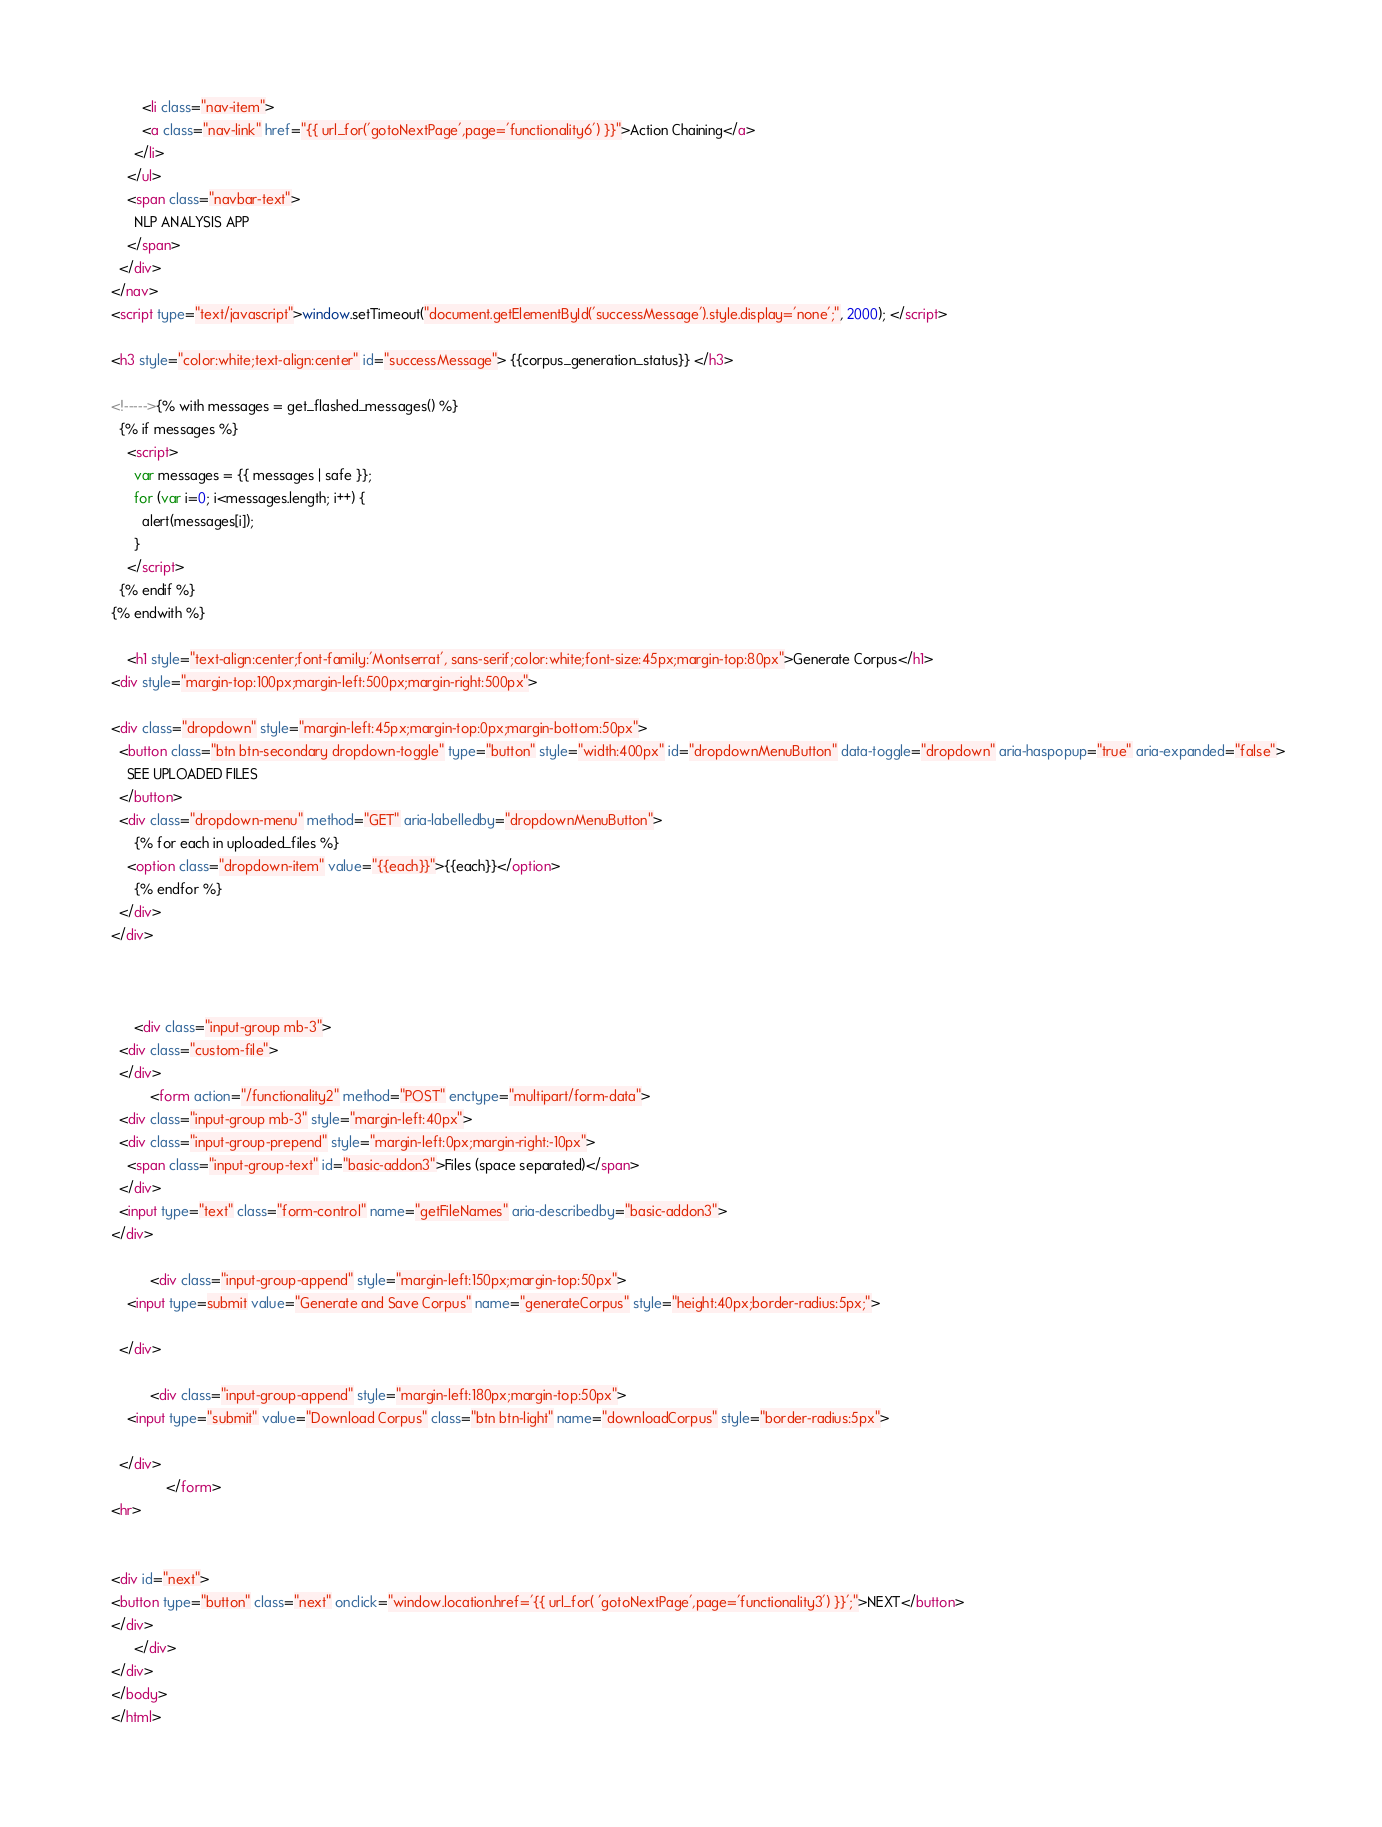Convert code to text. <code><loc_0><loc_0><loc_500><loc_500><_HTML_>        <li class="nav-item">
        <a class="nav-link" href="{{ url_for('gotoNextPage',page='functionality6') }}">Action Chaining</a>
      </li>
    </ul>
    <span class="navbar-text">
      NLP ANALYSIS APP
    </span>
  </div>
</nav>
<script type="text/javascript">window.setTimeout("document.getElementById('successMessage').style.display='none';", 2000); </script>

<h3 style="color:white;text-align:center" id="successMessage"> {{corpus_generation_status}} </h3>

<!----->{% with messages = get_flashed_messages() %}
  {% if messages %}
    <script>
      var messages = {{ messages | safe }};
      for (var i=0; i<messages.length; i++) {
        alert(messages[i]);
      }
    </script>
  {% endif %}
{% endwith %}

    <h1 style="text-align:center;font-family:'Montserrat', sans-serif;color:white;font-size:45px;margin-top:80px">Generate Corpus</h1>
<div style="margin-top:100px;margin-left:500px;margin-right:500px">

<div class="dropdown" style="margin-left:45px;margin-top:0px;margin-bottom:50px">
  <button class="btn btn-secondary dropdown-toggle" type="button" style="width:400px" id="dropdownMenuButton" data-toggle="dropdown" aria-haspopup="true" aria-expanded="false">
    SEE UPLOADED FILES
  </button>
  <div class="dropdown-menu" method="GET" aria-labelledby="dropdownMenuButton">
      {% for each in uploaded_files %}
    <option class="dropdown-item" value="{{each}}">{{each}}</option>
      {% endfor %}
  </div>
</div>



      <div class="input-group mb-3">
  <div class="custom-file">
  </div>
          <form action="/functionality2" method="POST" enctype="multipart/form-data">
  <div class="input-group mb-3" style="margin-left:40px">
  <div class="input-group-prepend" style="margin-left:0px;margin-right:-10px">
    <span class="input-group-text" id="basic-addon3">Files (space separated)</span>
  </div>
  <input type="text" class="form-control" name="getFileNames" aria-describedby="basic-addon3">
</div>

          <div class="input-group-append" style="margin-left:150px;margin-top:50px">
    <input type=submit value="Generate and Save Corpus" name="generateCorpus" style="height:40px;border-radius:5px;">

  </div>

          <div class="input-group-append" style="margin-left:180px;margin-top:50px">
    <input type="submit" value="Download Corpus" class="btn btn-light" name="downloadCorpus" style="border-radius:5px">

  </div>
              </form>
<hr>


<div id="next">
<button type="button" class="next" onclick="window.location.href='{{ url_for( 'gotoNextPage',page='functionality3') }}';">NEXT</button>
</div>
      </div>
</div>
</body>
</html></code> 